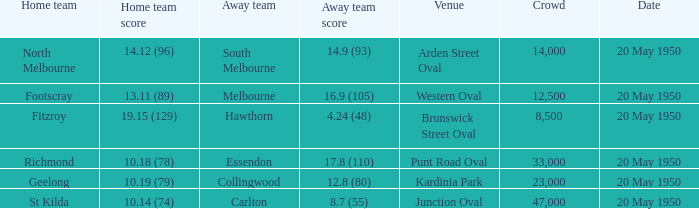8 (110)? 33000.0. 